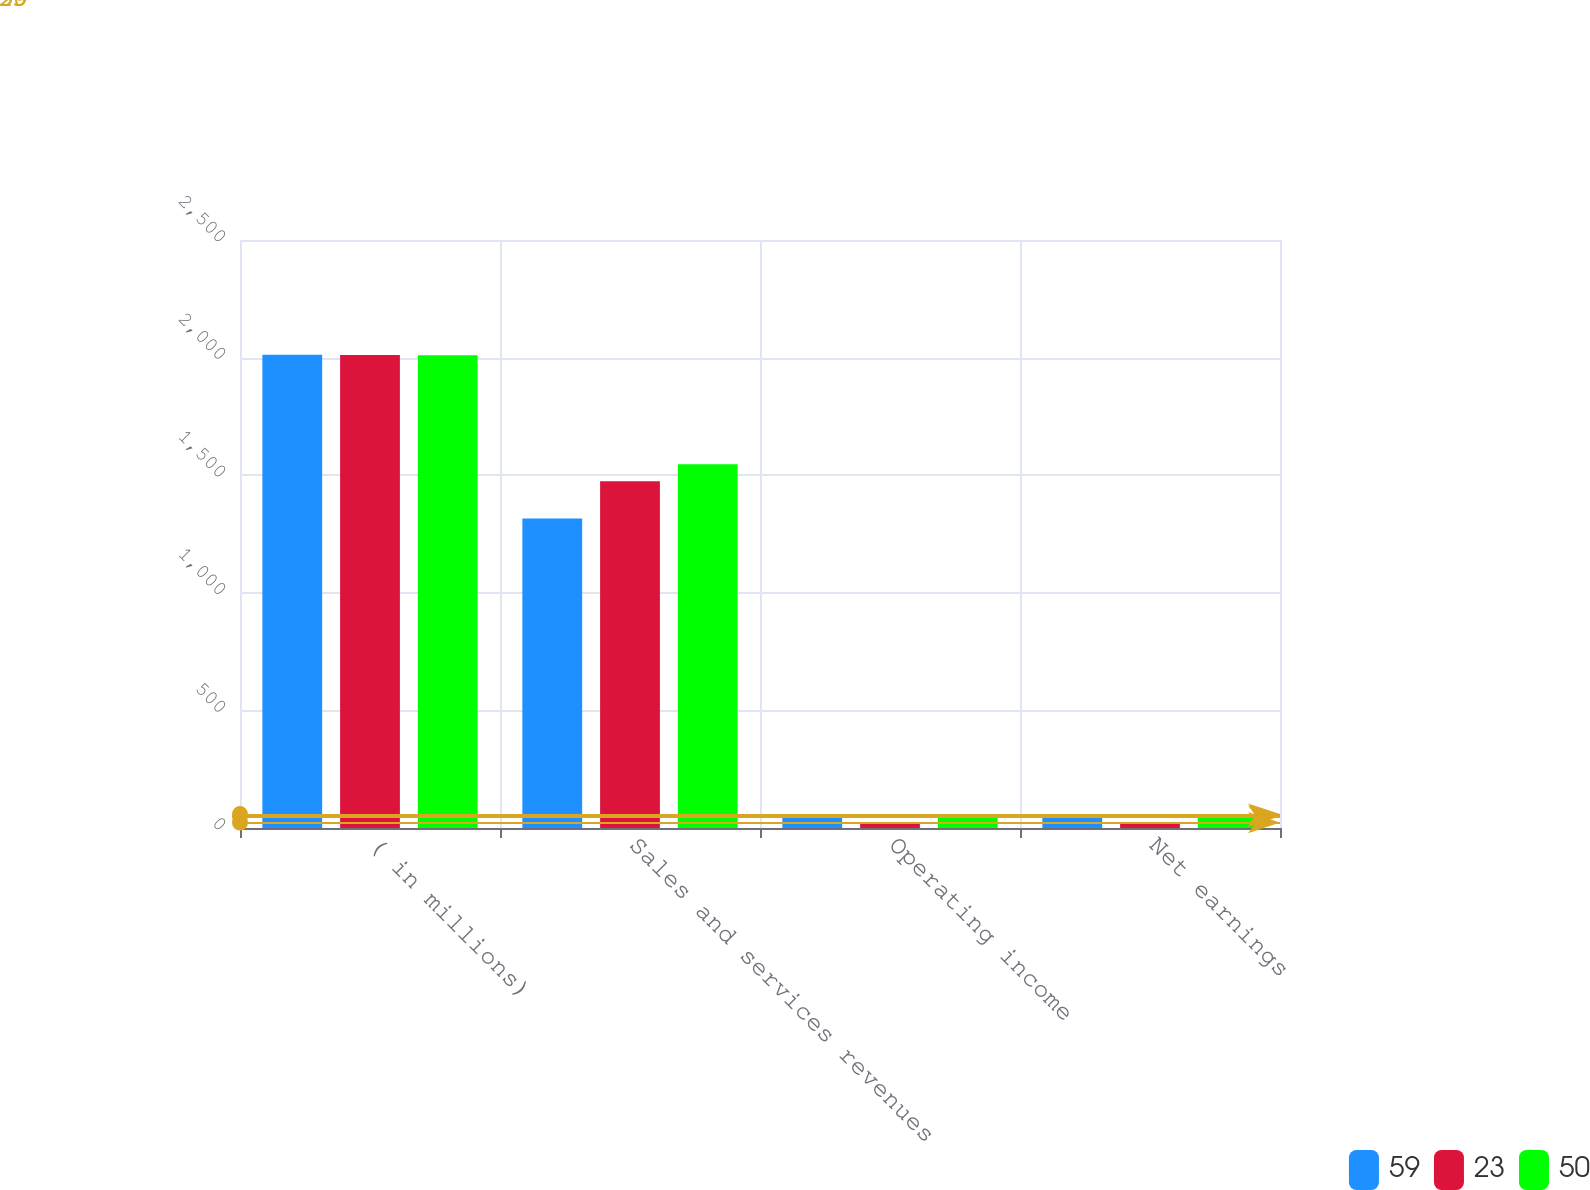Convert chart to OTSL. <chart><loc_0><loc_0><loc_500><loc_500><stacked_bar_chart><ecel><fcel>( in millions)<fcel>Sales and services revenues<fcel>Operating income<fcel>Net earnings<nl><fcel>59<fcel>2012<fcel>1316<fcel>50<fcel>50<nl><fcel>23<fcel>2011<fcel>1474<fcel>23<fcel>23<nl><fcel>50<fcel>2010<fcel>1547<fcel>59<fcel>59<nl></chart> 